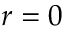Convert formula to latex. <formula><loc_0><loc_0><loc_500><loc_500>r = 0</formula> 